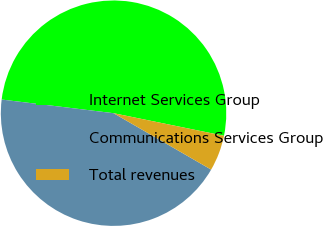Convert chart to OTSL. <chart><loc_0><loc_0><loc_500><loc_500><pie_chart><fcel>Internet Services Group<fcel>Communications Services Group<fcel>Total revenues<nl><fcel>51.28%<fcel>43.59%<fcel>5.13%<nl></chart> 